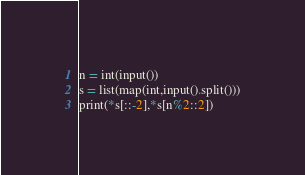Convert code to text. <code><loc_0><loc_0><loc_500><loc_500><_Python_>n = int(input())
s = list(map(int,input().split()))
print(*s[::-2],*s[n%2::2])</code> 